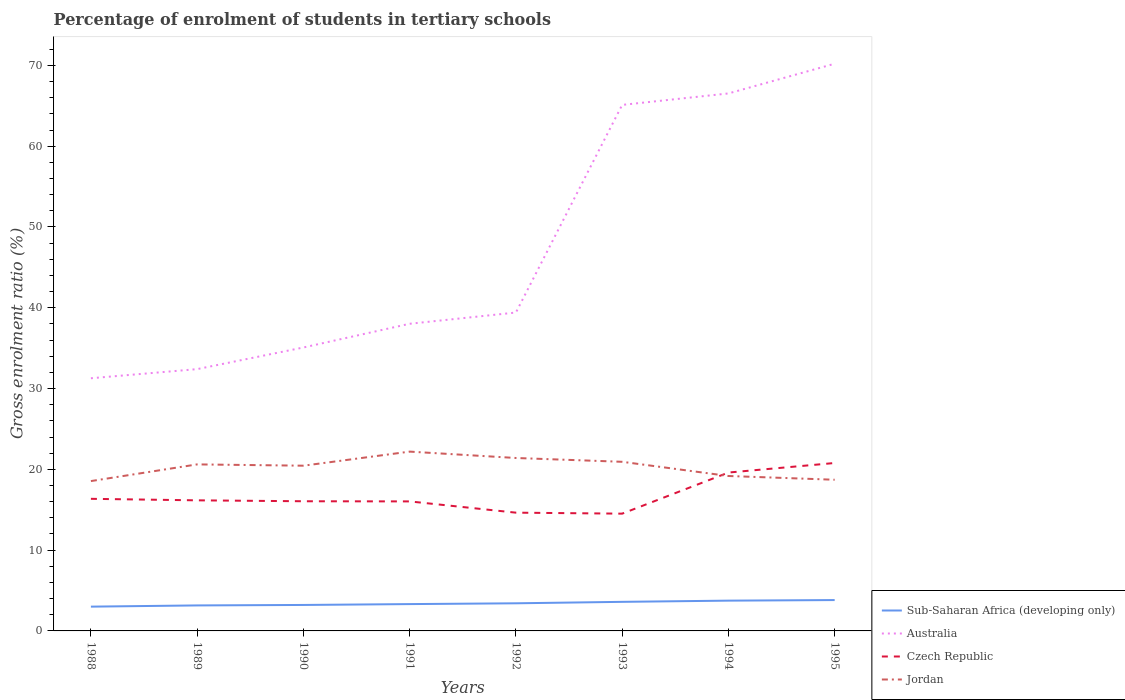Is the number of lines equal to the number of legend labels?
Keep it short and to the point. Yes. Across all years, what is the maximum percentage of students enrolled in tertiary schools in Australia?
Your answer should be very brief. 31.28. What is the total percentage of students enrolled in tertiary schools in Sub-Saharan Africa (developing only) in the graph?
Offer a terse response. -0.22. What is the difference between the highest and the second highest percentage of students enrolled in tertiary schools in Australia?
Keep it short and to the point. 38.93. What is the difference between two consecutive major ticks on the Y-axis?
Offer a very short reply. 10. Are the values on the major ticks of Y-axis written in scientific E-notation?
Make the answer very short. No. Where does the legend appear in the graph?
Give a very brief answer. Bottom right. What is the title of the graph?
Make the answer very short. Percentage of enrolment of students in tertiary schools. What is the label or title of the X-axis?
Provide a succinct answer. Years. What is the label or title of the Y-axis?
Your response must be concise. Gross enrolment ratio (%). What is the Gross enrolment ratio (%) in Sub-Saharan Africa (developing only) in 1988?
Give a very brief answer. 3. What is the Gross enrolment ratio (%) of Australia in 1988?
Ensure brevity in your answer.  31.28. What is the Gross enrolment ratio (%) in Czech Republic in 1988?
Ensure brevity in your answer.  16.35. What is the Gross enrolment ratio (%) in Jordan in 1988?
Offer a very short reply. 18.55. What is the Gross enrolment ratio (%) in Sub-Saharan Africa (developing only) in 1989?
Your answer should be very brief. 3.16. What is the Gross enrolment ratio (%) of Australia in 1989?
Ensure brevity in your answer.  32.41. What is the Gross enrolment ratio (%) of Czech Republic in 1989?
Your answer should be very brief. 16.16. What is the Gross enrolment ratio (%) in Jordan in 1989?
Offer a terse response. 20.61. What is the Gross enrolment ratio (%) in Sub-Saharan Africa (developing only) in 1990?
Make the answer very short. 3.21. What is the Gross enrolment ratio (%) of Australia in 1990?
Provide a succinct answer. 35.08. What is the Gross enrolment ratio (%) of Czech Republic in 1990?
Provide a short and direct response. 16.05. What is the Gross enrolment ratio (%) of Jordan in 1990?
Your answer should be compact. 20.45. What is the Gross enrolment ratio (%) in Sub-Saharan Africa (developing only) in 1991?
Your response must be concise. 3.32. What is the Gross enrolment ratio (%) of Australia in 1991?
Make the answer very short. 38.02. What is the Gross enrolment ratio (%) in Czech Republic in 1991?
Offer a very short reply. 16.03. What is the Gross enrolment ratio (%) of Jordan in 1991?
Your answer should be compact. 22.2. What is the Gross enrolment ratio (%) in Sub-Saharan Africa (developing only) in 1992?
Your answer should be very brief. 3.42. What is the Gross enrolment ratio (%) of Australia in 1992?
Give a very brief answer. 39.41. What is the Gross enrolment ratio (%) in Czech Republic in 1992?
Ensure brevity in your answer.  14.64. What is the Gross enrolment ratio (%) of Jordan in 1992?
Offer a terse response. 21.41. What is the Gross enrolment ratio (%) in Sub-Saharan Africa (developing only) in 1993?
Provide a short and direct response. 3.6. What is the Gross enrolment ratio (%) of Australia in 1993?
Give a very brief answer. 65.11. What is the Gross enrolment ratio (%) of Czech Republic in 1993?
Offer a very short reply. 14.52. What is the Gross enrolment ratio (%) in Jordan in 1993?
Ensure brevity in your answer.  20.93. What is the Gross enrolment ratio (%) in Sub-Saharan Africa (developing only) in 1994?
Ensure brevity in your answer.  3.75. What is the Gross enrolment ratio (%) in Australia in 1994?
Keep it short and to the point. 66.53. What is the Gross enrolment ratio (%) of Czech Republic in 1994?
Ensure brevity in your answer.  19.6. What is the Gross enrolment ratio (%) of Jordan in 1994?
Offer a terse response. 19.18. What is the Gross enrolment ratio (%) of Sub-Saharan Africa (developing only) in 1995?
Your answer should be compact. 3.82. What is the Gross enrolment ratio (%) of Australia in 1995?
Offer a very short reply. 70.21. What is the Gross enrolment ratio (%) of Czech Republic in 1995?
Your answer should be very brief. 20.79. What is the Gross enrolment ratio (%) in Jordan in 1995?
Ensure brevity in your answer.  18.71. Across all years, what is the maximum Gross enrolment ratio (%) in Sub-Saharan Africa (developing only)?
Provide a short and direct response. 3.82. Across all years, what is the maximum Gross enrolment ratio (%) in Australia?
Provide a short and direct response. 70.21. Across all years, what is the maximum Gross enrolment ratio (%) in Czech Republic?
Make the answer very short. 20.79. Across all years, what is the maximum Gross enrolment ratio (%) in Jordan?
Give a very brief answer. 22.2. Across all years, what is the minimum Gross enrolment ratio (%) of Sub-Saharan Africa (developing only)?
Your response must be concise. 3. Across all years, what is the minimum Gross enrolment ratio (%) in Australia?
Ensure brevity in your answer.  31.28. Across all years, what is the minimum Gross enrolment ratio (%) of Czech Republic?
Make the answer very short. 14.52. Across all years, what is the minimum Gross enrolment ratio (%) of Jordan?
Your answer should be compact. 18.55. What is the total Gross enrolment ratio (%) of Sub-Saharan Africa (developing only) in the graph?
Keep it short and to the point. 27.28. What is the total Gross enrolment ratio (%) in Australia in the graph?
Make the answer very short. 378.05. What is the total Gross enrolment ratio (%) in Czech Republic in the graph?
Your response must be concise. 134.14. What is the total Gross enrolment ratio (%) in Jordan in the graph?
Offer a very short reply. 162.04. What is the difference between the Gross enrolment ratio (%) of Sub-Saharan Africa (developing only) in 1988 and that in 1989?
Give a very brief answer. -0.15. What is the difference between the Gross enrolment ratio (%) of Australia in 1988 and that in 1989?
Your answer should be compact. -1.13. What is the difference between the Gross enrolment ratio (%) of Czech Republic in 1988 and that in 1989?
Keep it short and to the point. 0.19. What is the difference between the Gross enrolment ratio (%) in Jordan in 1988 and that in 1989?
Give a very brief answer. -2.07. What is the difference between the Gross enrolment ratio (%) of Sub-Saharan Africa (developing only) in 1988 and that in 1990?
Your answer should be compact. -0.21. What is the difference between the Gross enrolment ratio (%) in Australia in 1988 and that in 1990?
Offer a terse response. -3.81. What is the difference between the Gross enrolment ratio (%) of Czech Republic in 1988 and that in 1990?
Your response must be concise. 0.3. What is the difference between the Gross enrolment ratio (%) of Jordan in 1988 and that in 1990?
Provide a short and direct response. -1.9. What is the difference between the Gross enrolment ratio (%) in Sub-Saharan Africa (developing only) in 1988 and that in 1991?
Provide a succinct answer. -0.32. What is the difference between the Gross enrolment ratio (%) of Australia in 1988 and that in 1991?
Make the answer very short. -6.74. What is the difference between the Gross enrolment ratio (%) of Czech Republic in 1988 and that in 1991?
Provide a succinct answer. 0.32. What is the difference between the Gross enrolment ratio (%) of Jordan in 1988 and that in 1991?
Your answer should be very brief. -3.65. What is the difference between the Gross enrolment ratio (%) of Sub-Saharan Africa (developing only) in 1988 and that in 1992?
Offer a terse response. -0.41. What is the difference between the Gross enrolment ratio (%) of Australia in 1988 and that in 1992?
Give a very brief answer. -8.14. What is the difference between the Gross enrolment ratio (%) in Czech Republic in 1988 and that in 1992?
Offer a terse response. 1.71. What is the difference between the Gross enrolment ratio (%) in Jordan in 1988 and that in 1992?
Provide a short and direct response. -2.86. What is the difference between the Gross enrolment ratio (%) of Sub-Saharan Africa (developing only) in 1988 and that in 1993?
Ensure brevity in your answer.  -0.6. What is the difference between the Gross enrolment ratio (%) of Australia in 1988 and that in 1993?
Your answer should be very brief. -33.84. What is the difference between the Gross enrolment ratio (%) in Czech Republic in 1988 and that in 1993?
Offer a terse response. 1.84. What is the difference between the Gross enrolment ratio (%) in Jordan in 1988 and that in 1993?
Provide a short and direct response. -2.39. What is the difference between the Gross enrolment ratio (%) of Sub-Saharan Africa (developing only) in 1988 and that in 1994?
Offer a terse response. -0.74. What is the difference between the Gross enrolment ratio (%) of Australia in 1988 and that in 1994?
Make the answer very short. -35.25. What is the difference between the Gross enrolment ratio (%) of Czech Republic in 1988 and that in 1994?
Your answer should be very brief. -3.25. What is the difference between the Gross enrolment ratio (%) in Jordan in 1988 and that in 1994?
Your answer should be compact. -0.63. What is the difference between the Gross enrolment ratio (%) of Sub-Saharan Africa (developing only) in 1988 and that in 1995?
Keep it short and to the point. -0.81. What is the difference between the Gross enrolment ratio (%) in Australia in 1988 and that in 1995?
Your answer should be compact. -38.93. What is the difference between the Gross enrolment ratio (%) in Czech Republic in 1988 and that in 1995?
Your response must be concise. -4.43. What is the difference between the Gross enrolment ratio (%) in Jordan in 1988 and that in 1995?
Ensure brevity in your answer.  -0.16. What is the difference between the Gross enrolment ratio (%) of Sub-Saharan Africa (developing only) in 1989 and that in 1990?
Give a very brief answer. -0.06. What is the difference between the Gross enrolment ratio (%) in Australia in 1989 and that in 1990?
Make the answer very short. -2.68. What is the difference between the Gross enrolment ratio (%) in Czech Republic in 1989 and that in 1990?
Your response must be concise. 0.11. What is the difference between the Gross enrolment ratio (%) in Jordan in 1989 and that in 1990?
Ensure brevity in your answer.  0.16. What is the difference between the Gross enrolment ratio (%) in Sub-Saharan Africa (developing only) in 1989 and that in 1991?
Your response must be concise. -0.16. What is the difference between the Gross enrolment ratio (%) in Australia in 1989 and that in 1991?
Provide a succinct answer. -5.61. What is the difference between the Gross enrolment ratio (%) in Czech Republic in 1989 and that in 1991?
Provide a succinct answer. 0.13. What is the difference between the Gross enrolment ratio (%) in Jordan in 1989 and that in 1991?
Make the answer very short. -1.58. What is the difference between the Gross enrolment ratio (%) of Sub-Saharan Africa (developing only) in 1989 and that in 1992?
Offer a terse response. -0.26. What is the difference between the Gross enrolment ratio (%) of Australia in 1989 and that in 1992?
Give a very brief answer. -7.01. What is the difference between the Gross enrolment ratio (%) in Czech Republic in 1989 and that in 1992?
Offer a terse response. 1.53. What is the difference between the Gross enrolment ratio (%) in Jordan in 1989 and that in 1992?
Your answer should be compact. -0.79. What is the difference between the Gross enrolment ratio (%) in Sub-Saharan Africa (developing only) in 1989 and that in 1993?
Your response must be concise. -0.44. What is the difference between the Gross enrolment ratio (%) in Australia in 1989 and that in 1993?
Give a very brief answer. -32.7. What is the difference between the Gross enrolment ratio (%) of Czech Republic in 1989 and that in 1993?
Offer a terse response. 1.65. What is the difference between the Gross enrolment ratio (%) of Jordan in 1989 and that in 1993?
Your answer should be compact. -0.32. What is the difference between the Gross enrolment ratio (%) in Sub-Saharan Africa (developing only) in 1989 and that in 1994?
Ensure brevity in your answer.  -0.59. What is the difference between the Gross enrolment ratio (%) in Australia in 1989 and that in 1994?
Make the answer very short. -34.12. What is the difference between the Gross enrolment ratio (%) in Czech Republic in 1989 and that in 1994?
Your response must be concise. -3.44. What is the difference between the Gross enrolment ratio (%) in Jordan in 1989 and that in 1994?
Offer a very short reply. 1.44. What is the difference between the Gross enrolment ratio (%) in Sub-Saharan Africa (developing only) in 1989 and that in 1995?
Make the answer very short. -0.66. What is the difference between the Gross enrolment ratio (%) in Australia in 1989 and that in 1995?
Offer a very short reply. -37.8. What is the difference between the Gross enrolment ratio (%) in Czech Republic in 1989 and that in 1995?
Make the answer very short. -4.62. What is the difference between the Gross enrolment ratio (%) in Jordan in 1989 and that in 1995?
Offer a very short reply. 1.9. What is the difference between the Gross enrolment ratio (%) in Sub-Saharan Africa (developing only) in 1990 and that in 1991?
Provide a short and direct response. -0.11. What is the difference between the Gross enrolment ratio (%) of Australia in 1990 and that in 1991?
Your answer should be compact. -2.94. What is the difference between the Gross enrolment ratio (%) in Czech Republic in 1990 and that in 1991?
Your response must be concise. 0.02. What is the difference between the Gross enrolment ratio (%) in Jordan in 1990 and that in 1991?
Make the answer very short. -1.74. What is the difference between the Gross enrolment ratio (%) in Sub-Saharan Africa (developing only) in 1990 and that in 1992?
Your answer should be compact. -0.2. What is the difference between the Gross enrolment ratio (%) of Australia in 1990 and that in 1992?
Keep it short and to the point. -4.33. What is the difference between the Gross enrolment ratio (%) in Czech Republic in 1990 and that in 1992?
Offer a very short reply. 1.41. What is the difference between the Gross enrolment ratio (%) in Jordan in 1990 and that in 1992?
Offer a very short reply. -0.95. What is the difference between the Gross enrolment ratio (%) of Sub-Saharan Africa (developing only) in 1990 and that in 1993?
Offer a very short reply. -0.39. What is the difference between the Gross enrolment ratio (%) of Australia in 1990 and that in 1993?
Provide a short and direct response. -30.03. What is the difference between the Gross enrolment ratio (%) of Czech Republic in 1990 and that in 1993?
Make the answer very short. 1.53. What is the difference between the Gross enrolment ratio (%) in Jordan in 1990 and that in 1993?
Keep it short and to the point. -0.48. What is the difference between the Gross enrolment ratio (%) of Sub-Saharan Africa (developing only) in 1990 and that in 1994?
Your answer should be compact. -0.53. What is the difference between the Gross enrolment ratio (%) of Australia in 1990 and that in 1994?
Your response must be concise. -31.45. What is the difference between the Gross enrolment ratio (%) of Czech Republic in 1990 and that in 1994?
Provide a succinct answer. -3.55. What is the difference between the Gross enrolment ratio (%) in Jordan in 1990 and that in 1994?
Your response must be concise. 1.27. What is the difference between the Gross enrolment ratio (%) of Sub-Saharan Africa (developing only) in 1990 and that in 1995?
Make the answer very short. -0.6. What is the difference between the Gross enrolment ratio (%) in Australia in 1990 and that in 1995?
Ensure brevity in your answer.  -35.12. What is the difference between the Gross enrolment ratio (%) of Czech Republic in 1990 and that in 1995?
Your response must be concise. -4.74. What is the difference between the Gross enrolment ratio (%) of Jordan in 1990 and that in 1995?
Your answer should be compact. 1.74. What is the difference between the Gross enrolment ratio (%) of Sub-Saharan Africa (developing only) in 1991 and that in 1992?
Ensure brevity in your answer.  -0.1. What is the difference between the Gross enrolment ratio (%) of Australia in 1991 and that in 1992?
Offer a terse response. -1.39. What is the difference between the Gross enrolment ratio (%) in Czech Republic in 1991 and that in 1992?
Give a very brief answer. 1.39. What is the difference between the Gross enrolment ratio (%) of Jordan in 1991 and that in 1992?
Offer a terse response. 0.79. What is the difference between the Gross enrolment ratio (%) of Sub-Saharan Africa (developing only) in 1991 and that in 1993?
Offer a terse response. -0.28. What is the difference between the Gross enrolment ratio (%) in Australia in 1991 and that in 1993?
Offer a terse response. -27.09. What is the difference between the Gross enrolment ratio (%) of Czech Republic in 1991 and that in 1993?
Offer a terse response. 1.52. What is the difference between the Gross enrolment ratio (%) of Jordan in 1991 and that in 1993?
Your answer should be very brief. 1.26. What is the difference between the Gross enrolment ratio (%) of Sub-Saharan Africa (developing only) in 1991 and that in 1994?
Your answer should be very brief. -0.43. What is the difference between the Gross enrolment ratio (%) in Australia in 1991 and that in 1994?
Make the answer very short. -28.51. What is the difference between the Gross enrolment ratio (%) of Czech Republic in 1991 and that in 1994?
Offer a terse response. -3.57. What is the difference between the Gross enrolment ratio (%) in Jordan in 1991 and that in 1994?
Your answer should be compact. 3.02. What is the difference between the Gross enrolment ratio (%) of Sub-Saharan Africa (developing only) in 1991 and that in 1995?
Your response must be concise. -0.5. What is the difference between the Gross enrolment ratio (%) in Australia in 1991 and that in 1995?
Ensure brevity in your answer.  -32.19. What is the difference between the Gross enrolment ratio (%) in Czech Republic in 1991 and that in 1995?
Keep it short and to the point. -4.75. What is the difference between the Gross enrolment ratio (%) in Jordan in 1991 and that in 1995?
Offer a very short reply. 3.48. What is the difference between the Gross enrolment ratio (%) in Sub-Saharan Africa (developing only) in 1992 and that in 1993?
Ensure brevity in your answer.  -0.18. What is the difference between the Gross enrolment ratio (%) of Australia in 1992 and that in 1993?
Your answer should be compact. -25.7. What is the difference between the Gross enrolment ratio (%) in Czech Republic in 1992 and that in 1993?
Ensure brevity in your answer.  0.12. What is the difference between the Gross enrolment ratio (%) in Jordan in 1992 and that in 1993?
Make the answer very short. 0.47. What is the difference between the Gross enrolment ratio (%) in Sub-Saharan Africa (developing only) in 1992 and that in 1994?
Make the answer very short. -0.33. What is the difference between the Gross enrolment ratio (%) of Australia in 1992 and that in 1994?
Provide a succinct answer. -27.12. What is the difference between the Gross enrolment ratio (%) in Czech Republic in 1992 and that in 1994?
Keep it short and to the point. -4.97. What is the difference between the Gross enrolment ratio (%) in Jordan in 1992 and that in 1994?
Provide a succinct answer. 2.23. What is the difference between the Gross enrolment ratio (%) in Sub-Saharan Africa (developing only) in 1992 and that in 1995?
Give a very brief answer. -0.4. What is the difference between the Gross enrolment ratio (%) of Australia in 1992 and that in 1995?
Your answer should be compact. -30.8. What is the difference between the Gross enrolment ratio (%) of Czech Republic in 1992 and that in 1995?
Keep it short and to the point. -6.15. What is the difference between the Gross enrolment ratio (%) in Jordan in 1992 and that in 1995?
Make the answer very short. 2.69. What is the difference between the Gross enrolment ratio (%) of Sub-Saharan Africa (developing only) in 1993 and that in 1994?
Your answer should be very brief. -0.15. What is the difference between the Gross enrolment ratio (%) of Australia in 1993 and that in 1994?
Offer a terse response. -1.42. What is the difference between the Gross enrolment ratio (%) in Czech Republic in 1993 and that in 1994?
Your answer should be compact. -5.09. What is the difference between the Gross enrolment ratio (%) of Jordan in 1993 and that in 1994?
Your answer should be compact. 1.76. What is the difference between the Gross enrolment ratio (%) of Sub-Saharan Africa (developing only) in 1993 and that in 1995?
Provide a succinct answer. -0.22. What is the difference between the Gross enrolment ratio (%) of Australia in 1993 and that in 1995?
Your answer should be compact. -5.1. What is the difference between the Gross enrolment ratio (%) of Czech Republic in 1993 and that in 1995?
Keep it short and to the point. -6.27. What is the difference between the Gross enrolment ratio (%) of Jordan in 1993 and that in 1995?
Offer a very short reply. 2.22. What is the difference between the Gross enrolment ratio (%) in Sub-Saharan Africa (developing only) in 1994 and that in 1995?
Offer a terse response. -0.07. What is the difference between the Gross enrolment ratio (%) of Australia in 1994 and that in 1995?
Offer a terse response. -3.68. What is the difference between the Gross enrolment ratio (%) of Czech Republic in 1994 and that in 1995?
Provide a succinct answer. -1.18. What is the difference between the Gross enrolment ratio (%) in Jordan in 1994 and that in 1995?
Give a very brief answer. 0.47. What is the difference between the Gross enrolment ratio (%) in Sub-Saharan Africa (developing only) in 1988 and the Gross enrolment ratio (%) in Australia in 1989?
Your response must be concise. -29.4. What is the difference between the Gross enrolment ratio (%) of Sub-Saharan Africa (developing only) in 1988 and the Gross enrolment ratio (%) of Czech Republic in 1989?
Keep it short and to the point. -13.16. What is the difference between the Gross enrolment ratio (%) in Sub-Saharan Africa (developing only) in 1988 and the Gross enrolment ratio (%) in Jordan in 1989?
Your answer should be compact. -17.61. What is the difference between the Gross enrolment ratio (%) in Australia in 1988 and the Gross enrolment ratio (%) in Czech Republic in 1989?
Your answer should be very brief. 15.11. What is the difference between the Gross enrolment ratio (%) of Australia in 1988 and the Gross enrolment ratio (%) of Jordan in 1989?
Your answer should be compact. 10.66. What is the difference between the Gross enrolment ratio (%) in Czech Republic in 1988 and the Gross enrolment ratio (%) in Jordan in 1989?
Offer a very short reply. -4.26. What is the difference between the Gross enrolment ratio (%) of Sub-Saharan Africa (developing only) in 1988 and the Gross enrolment ratio (%) of Australia in 1990?
Provide a succinct answer. -32.08. What is the difference between the Gross enrolment ratio (%) of Sub-Saharan Africa (developing only) in 1988 and the Gross enrolment ratio (%) of Czech Republic in 1990?
Your answer should be very brief. -13.05. What is the difference between the Gross enrolment ratio (%) in Sub-Saharan Africa (developing only) in 1988 and the Gross enrolment ratio (%) in Jordan in 1990?
Provide a succinct answer. -17.45. What is the difference between the Gross enrolment ratio (%) in Australia in 1988 and the Gross enrolment ratio (%) in Czech Republic in 1990?
Provide a succinct answer. 15.22. What is the difference between the Gross enrolment ratio (%) of Australia in 1988 and the Gross enrolment ratio (%) of Jordan in 1990?
Make the answer very short. 10.82. What is the difference between the Gross enrolment ratio (%) in Czech Republic in 1988 and the Gross enrolment ratio (%) in Jordan in 1990?
Make the answer very short. -4.1. What is the difference between the Gross enrolment ratio (%) of Sub-Saharan Africa (developing only) in 1988 and the Gross enrolment ratio (%) of Australia in 1991?
Your response must be concise. -35.02. What is the difference between the Gross enrolment ratio (%) in Sub-Saharan Africa (developing only) in 1988 and the Gross enrolment ratio (%) in Czech Republic in 1991?
Give a very brief answer. -13.03. What is the difference between the Gross enrolment ratio (%) in Sub-Saharan Africa (developing only) in 1988 and the Gross enrolment ratio (%) in Jordan in 1991?
Give a very brief answer. -19.19. What is the difference between the Gross enrolment ratio (%) in Australia in 1988 and the Gross enrolment ratio (%) in Czech Republic in 1991?
Give a very brief answer. 15.24. What is the difference between the Gross enrolment ratio (%) of Australia in 1988 and the Gross enrolment ratio (%) of Jordan in 1991?
Provide a succinct answer. 9.08. What is the difference between the Gross enrolment ratio (%) of Czech Republic in 1988 and the Gross enrolment ratio (%) of Jordan in 1991?
Ensure brevity in your answer.  -5.84. What is the difference between the Gross enrolment ratio (%) of Sub-Saharan Africa (developing only) in 1988 and the Gross enrolment ratio (%) of Australia in 1992?
Provide a short and direct response. -36.41. What is the difference between the Gross enrolment ratio (%) in Sub-Saharan Africa (developing only) in 1988 and the Gross enrolment ratio (%) in Czech Republic in 1992?
Provide a succinct answer. -11.63. What is the difference between the Gross enrolment ratio (%) in Sub-Saharan Africa (developing only) in 1988 and the Gross enrolment ratio (%) in Jordan in 1992?
Provide a succinct answer. -18.4. What is the difference between the Gross enrolment ratio (%) in Australia in 1988 and the Gross enrolment ratio (%) in Czech Republic in 1992?
Make the answer very short. 16.64. What is the difference between the Gross enrolment ratio (%) of Australia in 1988 and the Gross enrolment ratio (%) of Jordan in 1992?
Your answer should be very brief. 9.87. What is the difference between the Gross enrolment ratio (%) in Czech Republic in 1988 and the Gross enrolment ratio (%) in Jordan in 1992?
Offer a terse response. -5.05. What is the difference between the Gross enrolment ratio (%) of Sub-Saharan Africa (developing only) in 1988 and the Gross enrolment ratio (%) of Australia in 1993?
Offer a very short reply. -62.11. What is the difference between the Gross enrolment ratio (%) in Sub-Saharan Africa (developing only) in 1988 and the Gross enrolment ratio (%) in Czech Republic in 1993?
Your answer should be very brief. -11.51. What is the difference between the Gross enrolment ratio (%) of Sub-Saharan Africa (developing only) in 1988 and the Gross enrolment ratio (%) of Jordan in 1993?
Your answer should be very brief. -17.93. What is the difference between the Gross enrolment ratio (%) in Australia in 1988 and the Gross enrolment ratio (%) in Czech Republic in 1993?
Offer a terse response. 16.76. What is the difference between the Gross enrolment ratio (%) in Australia in 1988 and the Gross enrolment ratio (%) in Jordan in 1993?
Your answer should be very brief. 10.34. What is the difference between the Gross enrolment ratio (%) in Czech Republic in 1988 and the Gross enrolment ratio (%) in Jordan in 1993?
Ensure brevity in your answer.  -4.58. What is the difference between the Gross enrolment ratio (%) of Sub-Saharan Africa (developing only) in 1988 and the Gross enrolment ratio (%) of Australia in 1994?
Provide a succinct answer. -63.53. What is the difference between the Gross enrolment ratio (%) in Sub-Saharan Africa (developing only) in 1988 and the Gross enrolment ratio (%) in Czech Republic in 1994?
Your response must be concise. -16.6. What is the difference between the Gross enrolment ratio (%) in Sub-Saharan Africa (developing only) in 1988 and the Gross enrolment ratio (%) in Jordan in 1994?
Give a very brief answer. -16.17. What is the difference between the Gross enrolment ratio (%) in Australia in 1988 and the Gross enrolment ratio (%) in Czech Republic in 1994?
Give a very brief answer. 11.67. What is the difference between the Gross enrolment ratio (%) of Australia in 1988 and the Gross enrolment ratio (%) of Jordan in 1994?
Offer a terse response. 12.1. What is the difference between the Gross enrolment ratio (%) of Czech Republic in 1988 and the Gross enrolment ratio (%) of Jordan in 1994?
Offer a very short reply. -2.83. What is the difference between the Gross enrolment ratio (%) of Sub-Saharan Africa (developing only) in 1988 and the Gross enrolment ratio (%) of Australia in 1995?
Your answer should be compact. -67.2. What is the difference between the Gross enrolment ratio (%) of Sub-Saharan Africa (developing only) in 1988 and the Gross enrolment ratio (%) of Czech Republic in 1995?
Keep it short and to the point. -17.78. What is the difference between the Gross enrolment ratio (%) in Sub-Saharan Africa (developing only) in 1988 and the Gross enrolment ratio (%) in Jordan in 1995?
Give a very brief answer. -15.71. What is the difference between the Gross enrolment ratio (%) in Australia in 1988 and the Gross enrolment ratio (%) in Czech Republic in 1995?
Make the answer very short. 10.49. What is the difference between the Gross enrolment ratio (%) in Australia in 1988 and the Gross enrolment ratio (%) in Jordan in 1995?
Your answer should be compact. 12.56. What is the difference between the Gross enrolment ratio (%) of Czech Republic in 1988 and the Gross enrolment ratio (%) of Jordan in 1995?
Ensure brevity in your answer.  -2.36. What is the difference between the Gross enrolment ratio (%) of Sub-Saharan Africa (developing only) in 1989 and the Gross enrolment ratio (%) of Australia in 1990?
Give a very brief answer. -31.93. What is the difference between the Gross enrolment ratio (%) of Sub-Saharan Africa (developing only) in 1989 and the Gross enrolment ratio (%) of Czech Republic in 1990?
Make the answer very short. -12.89. What is the difference between the Gross enrolment ratio (%) of Sub-Saharan Africa (developing only) in 1989 and the Gross enrolment ratio (%) of Jordan in 1990?
Provide a succinct answer. -17.3. What is the difference between the Gross enrolment ratio (%) in Australia in 1989 and the Gross enrolment ratio (%) in Czech Republic in 1990?
Provide a short and direct response. 16.36. What is the difference between the Gross enrolment ratio (%) in Australia in 1989 and the Gross enrolment ratio (%) in Jordan in 1990?
Your response must be concise. 11.95. What is the difference between the Gross enrolment ratio (%) in Czech Republic in 1989 and the Gross enrolment ratio (%) in Jordan in 1990?
Ensure brevity in your answer.  -4.29. What is the difference between the Gross enrolment ratio (%) in Sub-Saharan Africa (developing only) in 1989 and the Gross enrolment ratio (%) in Australia in 1991?
Ensure brevity in your answer.  -34.86. What is the difference between the Gross enrolment ratio (%) of Sub-Saharan Africa (developing only) in 1989 and the Gross enrolment ratio (%) of Czech Republic in 1991?
Offer a terse response. -12.88. What is the difference between the Gross enrolment ratio (%) of Sub-Saharan Africa (developing only) in 1989 and the Gross enrolment ratio (%) of Jordan in 1991?
Provide a succinct answer. -19.04. What is the difference between the Gross enrolment ratio (%) in Australia in 1989 and the Gross enrolment ratio (%) in Czech Republic in 1991?
Offer a very short reply. 16.37. What is the difference between the Gross enrolment ratio (%) of Australia in 1989 and the Gross enrolment ratio (%) of Jordan in 1991?
Keep it short and to the point. 10.21. What is the difference between the Gross enrolment ratio (%) of Czech Republic in 1989 and the Gross enrolment ratio (%) of Jordan in 1991?
Keep it short and to the point. -6.03. What is the difference between the Gross enrolment ratio (%) in Sub-Saharan Africa (developing only) in 1989 and the Gross enrolment ratio (%) in Australia in 1992?
Your answer should be very brief. -36.25. What is the difference between the Gross enrolment ratio (%) in Sub-Saharan Africa (developing only) in 1989 and the Gross enrolment ratio (%) in Czech Republic in 1992?
Offer a terse response. -11.48. What is the difference between the Gross enrolment ratio (%) of Sub-Saharan Africa (developing only) in 1989 and the Gross enrolment ratio (%) of Jordan in 1992?
Your answer should be very brief. -18.25. What is the difference between the Gross enrolment ratio (%) of Australia in 1989 and the Gross enrolment ratio (%) of Czech Republic in 1992?
Your answer should be very brief. 17.77. What is the difference between the Gross enrolment ratio (%) of Australia in 1989 and the Gross enrolment ratio (%) of Jordan in 1992?
Offer a terse response. 11. What is the difference between the Gross enrolment ratio (%) in Czech Republic in 1989 and the Gross enrolment ratio (%) in Jordan in 1992?
Your answer should be compact. -5.24. What is the difference between the Gross enrolment ratio (%) in Sub-Saharan Africa (developing only) in 1989 and the Gross enrolment ratio (%) in Australia in 1993?
Your answer should be very brief. -61.95. What is the difference between the Gross enrolment ratio (%) in Sub-Saharan Africa (developing only) in 1989 and the Gross enrolment ratio (%) in Czech Republic in 1993?
Give a very brief answer. -11.36. What is the difference between the Gross enrolment ratio (%) of Sub-Saharan Africa (developing only) in 1989 and the Gross enrolment ratio (%) of Jordan in 1993?
Ensure brevity in your answer.  -17.78. What is the difference between the Gross enrolment ratio (%) of Australia in 1989 and the Gross enrolment ratio (%) of Czech Republic in 1993?
Make the answer very short. 17.89. What is the difference between the Gross enrolment ratio (%) in Australia in 1989 and the Gross enrolment ratio (%) in Jordan in 1993?
Your answer should be compact. 11.47. What is the difference between the Gross enrolment ratio (%) of Czech Republic in 1989 and the Gross enrolment ratio (%) of Jordan in 1993?
Offer a very short reply. -4.77. What is the difference between the Gross enrolment ratio (%) of Sub-Saharan Africa (developing only) in 1989 and the Gross enrolment ratio (%) of Australia in 1994?
Keep it short and to the point. -63.37. What is the difference between the Gross enrolment ratio (%) of Sub-Saharan Africa (developing only) in 1989 and the Gross enrolment ratio (%) of Czech Republic in 1994?
Provide a succinct answer. -16.45. What is the difference between the Gross enrolment ratio (%) of Sub-Saharan Africa (developing only) in 1989 and the Gross enrolment ratio (%) of Jordan in 1994?
Your response must be concise. -16.02. What is the difference between the Gross enrolment ratio (%) of Australia in 1989 and the Gross enrolment ratio (%) of Czech Republic in 1994?
Your answer should be very brief. 12.8. What is the difference between the Gross enrolment ratio (%) in Australia in 1989 and the Gross enrolment ratio (%) in Jordan in 1994?
Offer a terse response. 13.23. What is the difference between the Gross enrolment ratio (%) of Czech Republic in 1989 and the Gross enrolment ratio (%) of Jordan in 1994?
Make the answer very short. -3.01. What is the difference between the Gross enrolment ratio (%) of Sub-Saharan Africa (developing only) in 1989 and the Gross enrolment ratio (%) of Australia in 1995?
Keep it short and to the point. -67.05. What is the difference between the Gross enrolment ratio (%) of Sub-Saharan Africa (developing only) in 1989 and the Gross enrolment ratio (%) of Czech Republic in 1995?
Your response must be concise. -17.63. What is the difference between the Gross enrolment ratio (%) of Sub-Saharan Africa (developing only) in 1989 and the Gross enrolment ratio (%) of Jordan in 1995?
Your answer should be very brief. -15.56. What is the difference between the Gross enrolment ratio (%) of Australia in 1989 and the Gross enrolment ratio (%) of Czech Republic in 1995?
Provide a short and direct response. 11.62. What is the difference between the Gross enrolment ratio (%) of Australia in 1989 and the Gross enrolment ratio (%) of Jordan in 1995?
Provide a short and direct response. 13.69. What is the difference between the Gross enrolment ratio (%) of Czech Republic in 1989 and the Gross enrolment ratio (%) of Jordan in 1995?
Make the answer very short. -2.55. What is the difference between the Gross enrolment ratio (%) in Sub-Saharan Africa (developing only) in 1990 and the Gross enrolment ratio (%) in Australia in 1991?
Your response must be concise. -34.81. What is the difference between the Gross enrolment ratio (%) in Sub-Saharan Africa (developing only) in 1990 and the Gross enrolment ratio (%) in Czech Republic in 1991?
Provide a short and direct response. -12.82. What is the difference between the Gross enrolment ratio (%) of Sub-Saharan Africa (developing only) in 1990 and the Gross enrolment ratio (%) of Jordan in 1991?
Make the answer very short. -18.98. What is the difference between the Gross enrolment ratio (%) in Australia in 1990 and the Gross enrolment ratio (%) in Czech Republic in 1991?
Give a very brief answer. 19.05. What is the difference between the Gross enrolment ratio (%) of Australia in 1990 and the Gross enrolment ratio (%) of Jordan in 1991?
Provide a short and direct response. 12.89. What is the difference between the Gross enrolment ratio (%) in Czech Republic in 1990 and the Gross enrolment ratio (%) in Jordan in 1991?
Ensure brevity in your answer.  -6.14. What is the difference between the Gross enrolment ratio (%) in Sub-Saharan Africa (developing only) in 1990 and the Gross enrolment ratio (%) in Australia in 1992?
Your answer should be compact. -36.2. What is the difference between the Gross enrolment ratio (%) in Sub-Saharan Africa (developing only) in 1990 and the Gross enrolment ratio (%) in Czech Republic in 1992?
Make the answer very short. -11.42. What is the difference between the Gross enrolment ratio (%) in Sub-Saharan Africa (developing only) in 1990 and the Gross enrolment ratio (%) in Jordan in 1992?
Your answer should be compact. -18.19. What is the difference between the Gross enrolment ratio (%) in Australia in 1990 and the Gross enrolment ratio (%) in Czech Republic in 1992?
Provide a short and direct response. 20.45. What is the difference between the Gross enrolment ratio (%) of Australia in 1990 and the Gross enrolment ratio (%) of Jordan in 1992?
Ensure brevity in your answer.  13.68. What is the difference between the Gross enrolment ratio (%) of Czech Republic in 1990 and the Gross enrolment ratio (%) of Jordan in 1992?
Ensure brevity in your answer.  -5.36. What is the difference between the Gross enrolment ratio (%) in Sub-Saharan Africa (developing only) in 1990 and the Gross enrolment ratio (%) in Australia in 1993?
Provide a succinct answer. -61.9. What is the difference between the Gross enrolment ratio (%) of Sub-Saharan Africa (developing only) in 1990 and the Gross enrolment ratio (%) of Czech Republic in 1993?
Your answer should be very brief. -11.3. What is the difference between the Gross enrolment ratio (%) of Sub-Saharan Africa (developing only) in 1990 and the Gross enrolment ratio (%) of Jordan in 1993?
Give a very brief answer. -17.72. What is the difference between the Gross enrolment ratio (%) in Australia in 1990 and the Gross enrolment ratio (%) in Czech Republic in 1993?
Offer a terse response. 20.57. What is the difference between the Gross enrolment ratio (%) in Australia in 1990 and the Gross enrolment ratio (%) in Jordan in 1993?
Offer a very short reply. 14.15. What is the difference between the Gross enrolment ratio (%) of Czech Republic in 1990 and the Gross enrolment ratio (%) of Jordan in 1993?
Provide a short and direct response. -4.88. What is the difference between the Gross enrolment ratio (%) in Sub-Saharan Africa (developing only) in 1990 and the Gross enrolment ratio (%) in Australia in 1994?
Make the answer very short. -63.32. What is the difference between the Gross enrolment ratio (%) of Sub-Saharan Africa (developing only) in 1990 and the Gross enrolment ratio (%) of Czech Republic in 1994?
Your answer should be compact. -16.39. What is the difference between the Gross enrolment ratio (%) in Sub-Saharan Africa (developing only) in 1990 and the Gross enrolment ratio (%) in Jordan in 1994?
Ensure brevity in your answer.  -15.96. What is the difference between the Gross enrolment ratio (%) in Australia in 1990 and the Gross enrolment ratio (%) in Czech Republic in 1994?
Provide a short and direct response. 15.48. What is the difference between the Gross enrolment ratio (%) in Australia in 1990 and the Gross enrolment ratio (%) in Jordan in 1994?
Provide a succinct answer. 15.91. What is the difference between the Gross enrolment ratio (%) of Czech Republic in 1990 and the Gross enrolment ratio (%) of Jordan in 1994?
Provide a succinct answer. -3.13. What is the difference between the Gross enrolment ratio (%) in Sub-Saharan Africa (developing only) in 1990 and the Gross enrolment ratio (%) in Australia in 1995?
Your answer should be compact. -66.99. What is the difference between the Gross enrolment ratio (%) in Sub-Saharan Africa (developing only) in 1990 and the Gross enrolment ratio (%) in Czech Republic in 1995?
Ensure brevity in your answer.  -17.57. What is the difference between the Gross enrolment ratio (%) of Sub-Saharan Africa (developing only) in 1990 and the Gross enrolment ratio (%) of Jordan in 1995?
Your answer should be compact. -15.5. What is the difference between the Gross enrolment ratio (%) of Australia in 1990 and the Gross enrolment ratio (%) of Czech Republic in 1995?
Give a very brief answer. 14.3. What is the difference between the Gross enrolment ratio (%) of Australia in 1990 and the Gross enrolment ratio (%) of Jordan in 1995?
Make the answer very short. 16.37. What is the difference between the Gross enrolment ratio (%) of Czech Republic in 1990 and the Gross enrolment ratio (%) of Jordan in 1995?
Your response must be concise. -2.66. What is the difference between the Gross enrolment ratio (%) in Sub-Saharan Africa (developing only) in 1991 and the Gross enrolment ratio (%) in Australia in 1992?
Give a very brief answer. -36.09. What is the difference between the Gross enrolment ratio (%) in Sub-Saharan Africa (developing only) in 1991 and the Gross enrolment ratio (%) in Czech Republic in 1992?
Your answer should be very brief. -11.32. What is the difference between the Gross enrolment ratio (%) in Sub-Saharan Africa (developing only) in 1991 and the Gross enrolment ratio (%) in Jordan in 1992?
Offer a very short reply. -18.09. What is the difference between the Gross enrolment ratio (%) of Australia in 1991 and the Gross enrolment ratio (%) of Czech Republic in 1992?
Provide a succinct answer. 23.38. What is the difference between the Gross enrolment ratio (%) of Australia in 1991 and the Gross enrolment ratio (%) of Jordan in 1992?
Your answer should be compact. 16.61. What is the difference between the Gross enrolment ratio (%) in Czech Republic in 1991 and the Gross enrolment ratio (%) in Jordan in 1992?
Make the answer very short. -5.37. What is the difference between the Gross enrolment ratio (%) in Sub-Saharan Africa (developing only) in 1991 and the Gross enrolment ratio (%) in Australia in 1993?
Offer a terse response. -61.79. What is the difference between the Gross enrolment ratio (%) of Sub-Saharan Africa (developing only) in 1991 and the Gross enrolment ratio (%) of Czech Republic in 1993?
Your response must be concise. -11.2. What is the difference between the Gross enrolment ratio (%) of Sub-Saharan Africa (developing only) in 1991 and the Gross enrolment ratio (%) of Jordan in 1993?
Your answer should be very brief. -17.61. What is the difference between the Gross enrolment ratio (%) in Australia in 1991 and the Gross enrolment ratio (%) in Czech Republic in 1993?
Ensure brevity in your answer.  23.5. What is the difference between the Gross enrolment ratio (%) in Australia in 1991 and the Gross enrolment ratio (%) in Jordan in 1993?
Provide a succinct answer. 17.09. What is the difference between the Gross enrolment ratio (%) in Czech Republic in 1991 and the Gross enrolment ratio (%) in Jordan in 1993?
Offer a very short reply. -4.9. What is the difference between the Gross enrolment ratio (%) of Sub-Saharan Africa (developing only) in 1991 and the Gross enrolment ratio (%) of Australia in 1994?
Your answer should be compact. -63.21. What is the difference between the Gross enrolment ratio (%) in Sub-Saharan Africa (developing only) in 1991 and the Gross enrolment ratio (%) in Czech Republic in 1994?
Give a very brief answer. -16.28. What is the difference between the Gross enrolment ratio (%) in Sub-Saharan Africa (developing only) in 1991 and the Gross enrolment ratio (%) in Jordan in 1994?
Offer a very short reply. -15.86. What is the difference between the Gross enrolment ratio (%) in Australia in 1991 and the Gross enrolment ratio (%) in Czech Republic in 1994?
Offer a terse response. 18.42. What is the difference between the Gross enrolment ratio (%) in Australia in 1991 and the Gross enrolment ratio (%) in Jordan in 1994?
Provide a succinct answer. 18.84. What is the difference between the Gross enrolment ratio (%) in Czech Republic in 1991 and the Gross enrolment ratio (%) in Jordan in 1994?
Give a very brief answer. -3.15. What is the difference between the Gross enrolment ratio (%) of Sub-Saharan Africa (developing only) in 1991 and the Gross enrolment ratio (%) of Australia in 1995?
Give a very brief answer. -66.89. What is the difference between the Gross enrolment ratio (%) of Sub-Saharan Africa (developing only) in 1991 and the Gross enrolment ratio (%) of Czech Republic in 1995?
Keep it short and to the point. -17.47. What is the difference between the Gross enrolment ratio (%) of Sub-Saharan Africa (developing only) in 1991 and the Gross enrolment ratio (%) of Jordan in 1995?
Provide a succinct answer. -15.39. What is the difference between the Gross enrolment ratio (%) in Australia in 1991 and the Gross enrolment ratio (%) in Czech Republic in 1995?
Provide a short and direct response. 17.23. What is the difference between the Gross enrolment ratio (%) in Australia in 1991 and the Gross enrolment ratio (%) in Jordan in 1995?
Provide a succinct answer. 19.31. What is the difference between the Gross enrolment ratio (%) in Czech Republic in 1991 and the Gross enrolment ratio (%) in Jordan in 1995?
Offer a terse response. -2.68. What is the difference between the Gross enrolment ratio (%) of Sub-Saharan Africa (developing only) in 1992 and the Gross enrolment ratio (%) of Australia in 1993?
Offer a terse response. -61.69. What is the difference between the Gross enrolment ratio (%) of Sub-Saharan Africa (developing only) in 1992 and the Gross enrolment ratio (%) of Czech Republic in 1993?
Give a very brief answer. -11.1. What is the difference between the Gross enrolment ratio (%) in Sub-Saharan Africa (developing only) in 1992 and the Gross enrolment ratio (%) in Jordan in 1993?
Make the answer very short. -17.52. What is the difference between the Gross enrolment ratio (%) of Australia in 1992 and the Gross enrolment ratio (%) of Czech Republic in 1993?
Offer a very short reply. 24.9. What is the difference between the Gross enrolment ratio (%) in Australia in 1992 and the Gross enrolment ratio (%) in Jordan in 1993?
Offer a terse response. 18.48. What is the difference between the Gross enrolment ratio (%) in Czech Republic in 1992 and the Gross enrolment ratio (%) in Jordan in 1993?
Make the answer very short. -6.3. What is the difference between the Gross enrolment ratio (%) of Sub-Saharan Africa (developing only) in 1992 and the Gross enrolment ratio (%) of Australia in 1994?
Make the answer very short. -63.11. What is the difference between the Gross enrolment ratio (%) in Sub-Saharan Africa (developing only) in 1992 and the Gross enrolment ratio (%) in Czech Republic in 1994?
Provide a succinct answer. -16.18. What is the difference between the Gross enrolment ratio (%) of Sub-Saharan Africa (developing only) in 1992 and the Gross enrolment ratio (%) of Jordan in 1994?
Make the answer very short. -15.76. What is the difference between the Gross enrolment ratio (%) in Australia in 1992 and the Gross enrolment ratio (%) in Czech Republic in 1994?
Offer a very short reply. 19.81. What is the difference between the Gross enrolment ratio (%) of Australia in 1992 and the Gross enrolment ratio (%) of Jordan in 1994?
Make the answer very short. 20.23. What is the difference between the Gross enrolment ratio (%) in Czech Republic in 1992 and the Gross enrolment ratio (%) in Jordan in 1994?
Your response must be concise. -4.54. What is the difference between the Gross enrolment ratio (%) of Sub-Saharan Africa (developing only) in 1992 and the Gross enrolment ratio (%) of Australia in 1995?
Make the answer very short. -66.79. What is the difference between the Gross enrolment ratio (%) in Sub-Saharan Africa (developing only) in 1992 and the Gross enrolment ratio (%) in Czech Republic in 1995?
Your answer should be compact. -17.37. What is the difference between the Gross enrolment ratio (%) in Sub-Saharan Africa (developing only) in 1992 and the Gross enrolment ratio (%) in Jordan in 1995?
Offer a very short reply. -15.29. What is the difference between the Gross enrolment ratio (%) in Australia in 1992 and the Gross enrolment ratio (%) in Czech Republic in 1995?
Give a very brief answer. 18.63. What is the difference between the Gross enrolment ratio (%) of Australia in 1992 and the Gross enrolment ratio (%) of Jordan in 1995?
Make the answer very short. 20.7. What is the difference between the Gross enrolment ratio (%) in Czech Republic in 1992 and the Gross enrolment ratio (%) in Jordan in 1995?
Provide a succinct answer. -4.07. What is the difference between the Gross enrolment ratio (%) of Sub-Saharan Africa (developing only) in 1993 and the Gross enrolment ratio (%) of Australia in 1994?
Provide a succinct answer. -62.93. What is the difference between the Gross enrolment ratio (%) of Sub-Saharan Africa (developing only) in 1993 and the Gross enrolment ratio (%) of Czech Republic in 1994?
Offer a very short reply. -16. What is the difference between the Gross enrolment ratio (%) in Sub-Saharan Africa (developing only) in 1993 and the Gross enrolment ratio (%) in Jordan in 1994?
Your response must be concise. -15.58. What is the difference between the Gross enrolment ratio (%) in Australia in 1993 and the Gross enrolment ratio (%) in Czech Republic in 1994?
Provide a succinct answer. 45.51. What is the difference between the Gross enrolment ratio (%) of Australia in 1993 and the Gross enrolment ratio (%) of Jordan in 1994?
Make the answer very short. 45.93. What is the difference between the Gross enrolment ratio (%) of Czech Republic in 1993 and the Gross enrolment ratio (%) of Jordan in 1994?
Keep it short and to the point. -4.66. What is the difference between the Gross enrolment ratio (%) in Sub-Saharan Africa (developing only) in 1993 and the Gross enrolment ratio (%) in Australia in 1995?
Keep it short and to the point. -66.61. What is the difference between the Gross enrolment ratio (%) in Sub-Saharan Africa (developing only) in 1993 and the Gross enrolment ratio (%) in Czech Republic in 1995?
Keep it short and to the point. -17.19. What is the difference between the Gross enrolment ratio (%) in Sub-Saharan Africa (developing only) in 1993 and the Gross enrolment ratio (%) in Jordan in 1995?
Offer a terse response. -15.11. What is the difference between the Gross enrolment ratio (%) in Australia in 1993 and the Gross enrolment ratio (%) in Czech Republic in 1995?
Provide a succinct answer. 44.33. What is the difference between the Gross enrolment ratio (%) in Australia in 1993 and the Gross enrolment ratio (%) in Jordan in 1995?
Provide a short and direct response. 46.4. What is the difference between the Gross enrolment ratio (%) of Czech Republic in 1993 and the Gross enrolment ratio (%) of Jordan in 1995?
Offer a very short reply. -4.2. What is the difference between the Gross enrolment ratio (%) of Sub-Saharan Africa (developing only) in 1994 and the Gross enrolment ratio (%) of Australia in 1995?
Your response must be concise. -66.46. What is the difference between the Gross enrolment ratio (%) of Sub-Saharan Africa (developing only) in 1994 and the Gross enrolment ratio (%) of Czech Republic in 1995?
Give a very brief answer. -17.04. What is the difference between the Gross enrolment ratio (%) of Sub-Saharan Africa (developing only) in 1994 and the Gross enrolment ratio (%) of Jordan in 1995?
Offer a terse response. -14.96. What is the difference between the Gross enrolment ratio (%) in Australia in 1994 and the Gross enrolment ratio (%) in Czech Republic in 1995?
Provide a short and direct response. 45.74. What is the difference between the Gross enrolment ratio (%) of Australia in 1994 and the Gross enrolment ratio (%) of Jordan in 1995?
Provide a succinct answer. 47.82. What is the difference between the Gross enrolment ratio (%) of Czech Republic in 1994 and the Gross enrolment ratio (%) of Jordan in 1995?
Your answer should be very brief. 0.89. What is the average Gross enrolment ratio (%) in Sub-Saharan Africa (developing only) per year?
Your answer should be very brief. 3.41. What is the average Gross enrolment ratio (%) in Australia per year?
Offer a terse response. 47.26. What is the average Gross enrolment ratio (%) in Czech Republic per year?
Give a very brief answer. 16.77. What is the average Gross enrolment ratio (%) in Jordan per year?
Offer a terse response. 20.25. In the year 1988, what is the difference between the Gross enrolment ratio (%) of Sub-Saharan Africa (developing only) and Gross enrolment ratio (%) of Australia?
Your answer should be compact. -28.27. In the year 1988, what is the difference between the Gross enrolment ratio (%) of Sub-Saharan Africa (developing only) and Gross enrolment ratio (%) of Czech Republic?
Your response must be concise. -13.35. In the year 1988, what is the difference between the Gross enrolment ratio (%) of Sub-Saharan Africa (developing only) and Gross enrolment ratio (%) of Jordan?
Your answer should be very brief. -15.54. In the year 1988, what is the difference between the Gross enrolment ratio (%) in Australia and Gross enrolment ratio (%) in Czech Republic?
Ensure brevity in your answer.  14.92. In the year 1988, what is the difference between the Gross enrolment ratio (%) of Australia and Gross enrolment ratio (%) of Jordan?
Keep it short and to the point. 12.73. In the year 1988, what is the difference between the Gross enrolment ratio (%) in Czech Republic and Gross enrolment ratio (%) in Jordan?
Provide a succinct answer. -2.2. In the year 1989, what is the difference between the Gross enrolment ratio (%) of Sub-Saharan Africa (developing only) and Gross enrolment ratio (%) of Australia?
Provide a succinct answer. -29.25. In the year 1989, what is the difference between the Gross enrolment ratio (%) of Sub-Saharan Africa (developing only) and Gross enrolment ratio (%) of Czech Republic?
Offer a terse response. -13.01. In the year 1989, what is the difference between the Gross enrolment ratio (%) in Sub-Saharan Africa (developing only) and Gross enrolment ratio (%) in Jordan?
Your answer should be very brief. -17.46. In the year 1989, what is the difference between the Gross enrolment ratio (%) in Australia and Gross enrolment ratio (%) in Czech Republic?
Offer a very short reply. 16.24. In the year 1989, what is the difference between the Gross enrolment ratio (%) in Australia and Gross enrolment ratio (%) in Jordan?
Provide a short and direct response. 11.79. In the year 1989, what is the difference between the Gross enrolment ratio (%) of Czech Republic and Gross enrolment ratio (%) of Jordan?
Offer a terse response. -4.45. In the year 1990, what is the difference between the Gross enrolment ratio (%) of Sub-Saharan Africa (developing only) and Gross enrolment ratio (%) of Australia?
Offer a terse response. -31.87. In the year 1990, what is the difference between the Gross enrolment ratio (%) in Sub-Saharan Africa (developing only) and Gross enrolment ratio (%) in Czech Republic?
Keep it short and to the point. -12.84. In the year 1990, what is the difference between the Gross enrolment ratio (%) of Sub-Saharan Africa (developing only) and Gross enrolment ratio (%) of Jordan?
Give a very brief answer. -17.24. In the year 1990, what is the difference between the Gross enrolment ratio (%) of Australia and Gross enrolment ratio (%) of Czech Republic?
Offer a terse response. 19.03. In the year 1990, what is the difference between the Gross enrolment ratio (%) of Australia and Gross enrolment ratio (%) of Jordan?
Give a very brief answer. 14.63. In the year 1990, what is the difference between the Gross enrolment ratio (%) in Czech Republic and Gross enrolment ratio (%) in Jordan?
Make the answer very short. -4.4. In the year 1991, what is the difference between the Gross enrolment ratio (%) of Sub-Saharan Africa (developing only) and Gross enrolment ratio (%) of Australia?
Make the answer very short. -34.7. In the year 1991, what is the difference between the Gross enrolment ratio (%) of Sub-Saharan Africa (developing only) and Gross enrolment ratio (%) of Czech Republic?
Your response must be concise. -12.71. In the year 1991, what is the difference between the Gross enrolment ratio (%) of Sub-Saharan Africa (developing only) and Gross enrolment ratio (%) of Jordan?
Your response must be concise. -18.87. In the year 1991, what is the difference between the Gross enrolment ratio (%) of Australia and Gross enrolment ratio (%) of Czech Republic?
Keep it short and to the point. 21.99. In the year 1991, what is the difference between the Gross enrolment ratio (%) of Australia and Gross enrolment ratio (%) of Jordan?
Offer a very short reply. 15.82. In the year 1991, what is the difference between the Gross enrolment ratio (%) in Czech Republic and Gross enrolment ratio (%) in Jordan?
Make the answer very short. -6.16. In the year 1992, what is the difference between the Gross enrolment ratio (%) in Sub-Saharan Africa (developing only) and Gross enrolment ratio (%) in Australia?
Provide a succinct answer. -35.99. In the year 1992, what is the difference between the Gross enrolment ratio (%) of Sub-Saharan Africa (developing only) and Gross enrolment ratio (%) of Czech Republic?
Offer a very short reply. -11.22. In the year 1992, what is the difference between the Gross enrolment ratio (%) in Sub-Saharan Africa (developing only) and Gross enrolment ratio (%) in Jordan?
Your answer should be compact. -17.99. In the year 1992, what is the difference between the Gross enrolment ratio (%) in Australia and Gross enrolment ratio (%) in Czech Republic?
Your answer should be compact. 24.77. In the year 1992, what is the difference between the Gross enrolment ratio (%) of Australia and Gross enrolment ratio (%) of Jordan?
Your answer should be very brief. 18.01. In the year 1992, what is the difference between the Gross enrolment ratio (%) in Czech Republic and Gross enrolment ratio (%) in Jordan?
Your response must be concise. -6.77. In the year 1993, what is the difference between the Gross enrolment ratio (%) of Sub-Saharan Africa (developing only) and Gross enrolment ratio (%) of Australia?
Ensure brevity in your answer.  -61.51. In the year 1993, what is the difference between the Gross enrolment ratio (%) in Sub-Saharan Africa (developing only) and Gross enrolment ratio (%) in Czech Republic?
Your answer should be very brief. -10.92. In the year 1993, what is the difference between the Gross enrolment ratio (%) in Sub-Saharan Africa (developing only) and Gross enrolment ratio (%) in Jordan?
Keep it short and to the point. -17.33. In the year 1993, what is the difference between the Gross enrolment ratio (%) of Australia and Gross enrolment ratio (%) of Czech Republic?
Your answer should be compact. 50.6. In the year 1993, what is the difference between the Gross enrolment ratio (%) in Australia and Gross enrolment ratio (%) in Jordan?
Offer a terse response. 44.18. In the year 1993, what is the difference between the Gross enrolment ratio (%) of Czech Republic and Gross enrolment ratio (%) of Jordan?
Ensure brevity in your answer.  -6.42. In the year 1994, what is the difference between the Gross enrolment ratio (%) in Sub-Saharan Africa (developing only) and Gross enrolment ratio (%) in Australia?
Provide a short and direct response. -62.78. In the year 1994, what is the difference between the Gross enrolment ratio (%) of Sub-Saharan Africa (developing only) and Gross enrolment ratio (%) of Czech Republic?
Offer a very short reply. -15.86. In the year 1994, what is the difference between the Gross enrolment ratio (%) in Sub-Saharan Africa (developing only) and Gross enrolment ratio (%) in Jordan?
Ensure brevity in your answer.  -15.43. In the year 1994, what is the difference between the Gross enrolment ratio (%) in Australia and Gross enrolment ratio (%) in Czech Republic?
Provide a succinct answer. 46.93. In the year 1994, what is the difference between the Gross enrolment ratio (%) in Australia and Gross enrolment ratio (%) in Jordan?
Make the answer very short. 47.35. In the year 1994, what is the difference between the Gross enrolment ratio (%) in Czech Republic and Gross enrolment ratio (%) in Jordan?
Offer a terse response. 0.43. In the year 1995, what is the difference between the Gross enrolment ratio (%) in Sub-Saharan Africa (developing only) and Gross enrolment ratio (%) in Australia?
Your answer should be very brief. -66.39. In the year 1995, what is the difference between the Gross enrolment ratio (%) in Sub-Saharan Africa (developing only) and Gross enrolment ratio (%) in Czech Republic?
Offer a terse response. -16.97. In the year 1995, what is the difference between the Gross enrolment ratio (%) in Sub-Saharan Africa (developing only) and Gross enrolment ratio (%) in Jordan?
Ensure brevity in your answer.  -14.89. In the year 1995, what is the difference between the Gross enrolment ratio (%) of Australia and Gross enrolment ratio (%) of Czech Republic?
Offer a terse response. 49.42. In the year 1995, what is the difference between the Gross enrolment ratio (%) in Australia and Gross enrolment ratio (%) in Jordan?
Your response must be concise. 51.5. In the year 1995, what is the difference between the Gross enrolment ratio (%) of Czech Republic and Gross enrolment ratio (%) of Jordan?
Your answer should be very brief. 2.07. What is the ratio of the Gross enrolment ratio (%) of Sub-Saharan Africa (developing only) in 1988 to that in 1989?
Your answer should be very brief. 0.95. What is the ratio of the Gross enrolment ratio (%) of Australia in 1988 to that in 1989?
Keep it short and to the point. 0.97. What is the ratio of the Gross enrolment ratio (%) of Czech Republic in 1988 to that in 1989?
Ensure brevity in your answer.  1.01. What is the ratio of the Gross enrolment ratio (%) in Jordan in 1988 to that in 1989?
Make the answer very short. 0.9. What is the ratio of the Gross enrolment ratio (%) of Sub-Saharan Africa (developing only) in 1988 to that in 1990?
Ensure brevity in your answer.  0.93. What is the ratio of the Gross enrolment ratio (%) in Australia in 1988 to that in 1990?
Give a very brief answer. 0.89. What is the ratio of the Gross enrolment ratio (%) of Czech Republic in 1988 to that in 1990?
Offer a terse response. 1.02. What is the ratio of the Gross enrolment ratio (%) in Jordan in 1988 to that in 1990?
Give a very brief answer. 0.91. What is the ratio of the Gross enrolment ratio (%) in Sub-Saharan Africa (developing only) in 1988 to that in 1991?
Make the answer very short. 0.9. What is the ratio of the Gross enrolment ratio (%) of Australia in 1988 to that in 1991?
Make the answer very short. 0.82. What is the ratio of the Gross enrolment ratio (%) in Czech Republic in 1988 to that in 1991?
Your response must be concise. 1.02. What is the ratio of the Gross enrolment ratio (%) of Jordan in 1988 to that in 1991?
Ensure brevity in your answer.  0.84. What is the ratio of the Gross enrolment ratio (%) in Sub-Saharan Africa (developing only) in 1988 to that in 1992?
Make the answer very short. 0.88. What is the ratio of the Gross enrolment ratio (%) in Australia in 1988 to that in 1992?
Offer a terse response. 0.79. What is the ratio of the Gross enrolment ratio (%) of Czech Republic in 1988 to that in 1992?
Your answer should be very brief. 1.12. What is the ratio of the Gross enrolment ratio (%) in Jordan in 1988 to that in 1992?
Your response must be concise. 0.87. What is the ratio of the Gross enrolment ratio (%) of Sub-Saharan Africa (developing only) in 1988 to that in 1993?
Ensure brevity in your answer.  0.83. What is the ratio of the Gross enrolment ratio (%) in Australia in 1988 to that in 1993?
Your answer should be compact. 0.48. What is the ratio of the Gross enrolment ratio (%) in Czech Republic in 1988 to that in 1993?
Make the answer very short. 1.13. What is the ratio of the Gross enrolment ratio (%) of Jordan in 1988 to that in 1993?
Make the answer very short. 0.89. What is the ratio of the Gross enrolment ratio (%) of Sub-Saharan Africa (developing only) in 1988 to that in 1994?
Offer a terse response. 0.8. What is the ratio of the Gross enrolment ratio (%) in Australia in 1988 to that in 1994?
Ensure brevity in your answer.  0.47. What is the ratio of the Gross enrolment ratio (%) in Czech Republic in 1988 to that in 1994?
Keep it short and to the point. 0.83. What is the ratio of the Gross enrolment ratio (%) in Jordan in 1988 to that in 1994?
Offer a terse response. 0.97. What is the ratio of the Gross enrolment ratio (%) of Sub-Saharan Africa (developing only) in 1988 to that in 1995?
Provide a succinct answer. 0.79. What is the ratio of the Gross enrolment ratio (%) of Australia in 1988 to that in 1995?
Your answer should be compact. 0.45. What is the ratio of the Gross enrolment ratio (%) of Czech Republic in 1988 to that in 1995?
Provide a short and direct response. 0.79. What is the ratio of the Gross enrolment ratio (%) of Sub-Saharan Africa (developing only) in 1989 to that in 1990?
Provide a short and direct response. 0.98. What is the ratio of the Gross enrolment ratio (%) of Australia in 1989 to that in 1990?
Ensure brevity in your answer.  0.92. What is the ratio of the Gross enrolment ratio (%) in Czech Republic in 1989 to that in 1990?
Keep it short and to the point. 1.01. What is the ratio of the Gross enrolment ratio (%) in Jordan in 1989 to that in 1990?
Offer a very short reply. 1.01. What is the ratio of the Gross enrolment ratio (%) of Sub-Saharan Africa (developing only) in 1989 to that in 1991?
Your answer should be very brief. 0.95. What is the ratio of the Gross enrolment ratio (%) of Australia in 1989 to that in 1991?
Your answer should be compact. 0.85. What is the ratio of the Gross enrolment ratio (%) of Czech Republic in 1989 to that in 1991?
Provide a short and direct response. 1.01. What is the ratio of the Gross enrolment ratio (%) in Jordan in 1989 to that in 1991?
Ensure brevity in your answer.  0.93. What is the ratio of the Gross enrolment ratio (%) in Sub-Saharan Africa (developing only) in 1989 to that in 1992?
Your answer should be very brief. 0.92. What is the ratio of the Gross enrolment ratio (%) of Australia in 1989 to that in 1992?
Offer a very short reply. 0.82. What is the ratio of the Gross enrolment ratio (%) of Czech Republic in 1989 to that in 1992?
Give a very brief answer. 1.1. What is the ratio of the Gross enrolment ratio (%) in Sub-Saharan Africa (developing only) in 1989 to that in 1993?
Your response must be concise. 0.88. What is the ratio of the Gross enrolment ratio (%) of Australia in 1989 to that in 1993?
Your answer should be very brief. 0.5. What is the ratio of the Gross enrolment ratio (%) in Czech Republic in 1989 to that in 1993?
Offer a very short reply. 1.11. What is the ratio of the Gross enrolment ratio (%) of Jordan in 1989 to that in 1993?
Give a very brief answer. 0.98. What is the ratio of the Gross enrolment ratio (%) of Sub-Saharan Africa (developing only) in 1989 to that in 1994?
Keep it short and to the point. 0.84. What is the ratio of the Gross enrolment ratio (%) of Australia in 1989 to that in 1994?
Your answer should be very brief. 0.49. What is the ratio of the Gross enrolment ratio (%) in Czech Republic in 1989 to that in 1994?
Provide a short and direct response. 0.82. What is the ratio of the Gross enrolment ratio (%) in Jordan in 1989 to that in 1994?
Keep it short and to the point. 1.07. What is the ratio of the Gross enrolment ratio (%) in Sub-Saharan Africa (developing only) in 1989 to that in 1995?
Give a very brief answer. 0.83. What is the ratio of the Gross enrolment ratio (%) in Australia in 1989 to that in 1995?
Offer a terse response. 0.46. What is the ratio of the Gross enrolment ratio (%) in Czech Republic in 1989 to that in 1995?
Offer a very short reply. 0.78. What is the ratio of the Gross enrolment ratio (%) in Jordan in 1989 to that in 1995?
Keep it short and to the point. 1.1. What is the ratio of the Gross enrolment ratio (%) of Australia in 1990 to that in 1991?
Offer a terse response. 0.92. What is the ratio of the Gross enrolment ratio (%) of Czech Republic in 1990 to that in 1991?
Offer a terse response. 1. What is the ratio of the Gross enrolment ratio (%) in Jordan in 1990 to that in 1991?
Your response must be concise. 0.92. What is the ratio of the Gross enrolment ratio (%) of Sub-Saharan Africa (developing only) in 1990 to that in 1992?
Keep it short and to the point. 0.94. What is the ratio of the Gross enrolment ratio (%) of Australia in 1990 to that in 1992?
Give a very brief answer. 0.89. What is the ratio of the Gross enrolment ratio (%) of Czech Republic in 1990 to that in 1992?
Offer a terse response. 1.1. What is the ratio of the Gross enrolment ratio (%) of Jordan in 1990 to that in 1992?
Ensure brevity in your answer.  0.96. What is the ratio of the Gross enrolment ratio (%) of Sub-Saharan Africa (developing only) in 1990 to that in 1993?
Offer a terse response. 0.89. What is the ratio of the Gross enrolment ratio (%) in Australia in 1990 to that in 1993?
Your answer should be very brief. 0.54. What is the ratio of the Gross enrolment ratio (%) in Czech Republic in 1990 to that in 1993?
Make the answer very short. 1.11. What is the ratio of the Gross enrolment ratio (%) of Jordan in 1990 to that in 1993?
Ensure brevity in your answer.  0.98. What is the ratio of the Gross enrolment ratio (%) in Sub-Saharan Africa (developing only) in 1990 to that in 1994?
Your answer should be compact. 0.86. What is the ratio of the Gross enrolment ratio (%) in Australia in 1990 to that in 1994?
Keep it short and to the point. 0.53. What is the ratio of the Gross enrolment ratio (%) of Czech Republic in 1990 to that in 1994?
Your answer should be compact. 0.82. What is the ratio of the Gross enrolment ratio (%) of Jordan in 1990 to that in 1994?
Provide a succinct answer. 1.07. What is the ratio of the Gross enrolment ratio (%) of Sub-Saharan Africa (developing only) in 1990 to that in 1995?
Provide a short and direct response. 0.84. What is the ratio of the Gross enrolment ratio (%) in Australia in 1990 to that in 1995?
Your response must be concise. 0.5. What is the ratio of the Gross enrolment ratio (%) of Czech Republic in 1990 to that in 1995?
Your answer should be compact. 0.77. What is the ratio of the Gross enrolment ratio (%) of Jordan in 1990 to that in 1995?
Provide a succinct answer. 1.09. What is the ratio of the Gross enrolment ratio (%) in Sub-Saharan Africa (developing only) in 1991 to that in 1992?
Offer a very short reply. 0.97. What is the ratio of the Gross enrolment ratio (%) of Australia in 1991 to that in 1992?
Provide a succinct answer. 0.96. What is the ratio of the Gross enrolment ratio (%) in Czech Republic in 1991 to that in 1992?
Provide a short and direct response. 1.1. What is the ratio of the Gross enrolment ratio (%) of Jordan in 1991 to that in 1992?
Provide a succinct answer. 1.04. What is the ratio of the Gross enrolment ratio (%) of Sub-Saharan Africa (developing only) in 1991 to that in 1993?
Keep it short and to the point. 0.92. What is the ratio of the Gross enrolment ratio (%) of Australia in 1991 to that in 1993?
Your answer should be very brief. 0.58. What is the ratio of the Gross enrolment ratio (%) of Czech Republic in 1991 to that in 1993?
Provide a short and direct response. 1.1. What is the ratio of the Gross enrolment ratio (%) in Jordan in 1991 to that in 1993?
Keep it short and to the point. 1.06. What is the ratio of the Gross enrolment ratio (%) of Sub-Saharan Africa (developing only) in 1991 to that in 1994?
Offer a very short reply. 0.89. What is the ratio of the Gross enrolment ratio (%) in Australia in 1991 to that in 1994?
Your answer should be compact. 0.57. What is the ratio of the Gross enrolment ratio (%) of Czech Republic in 1991 to that in 1994?
Provide a succinct answer. 0.82. What is the ratio of the Gross enrolment ratio (%) in Jordan in 1991 to that in 1994?
Provide a succinct answer. 1.16. What is the ratio of the Gross enrolment ratio (%) of Sub-Saharan Africa (developing only) in 1991 to that in 1995?
Ensure brevity in your answer.  0.87. What is the ratio of the Gross enrolment ratio (%) in Australia in 1991 to that in 1995?
Provide a succinct answer. 0.54. What is the ratio of the Gross enrolment ratio (%) in Czech Republic in 1991 to that in 1995?
Give a very brief answer. 0.77. What is the ratio of the Gross enrolment ratio (%) in Jordan in 1991 to that in 1995?
Give a very brief answer. 1.19. What is the ratio of the Gross enrolment ratio (%) of Sub-Saharan Africa (developing only) in 1992 to that in 1993?
Ensure brevity in your answer.  0.95. What is the ratio of the Gross enrolment ratio (%) of Australia in 1992 to that in 1993?
Offer a very short reply. 0.61. What is the ratio of the Gross enrolment ratio (%) of Czech Republic in 1992 to that in 1993?
Your response must be concise. 1.01. What is the ratio of the Gross enrolment ratio (%) in Jordan in 1992 to that in 1993?
Ensure brevity in your answer.  1.02. What is the ratio of the Gross enrolment ratio (%) in Sub-Saharan Africa (developing only) in 1992 to that in 1994?
Make the answer very short. 0.91. What is the ratio of the Gross enrolment ratio (%) in Australia in 1992 to that in 1994?
Your response must be concise. 0.59. What is the ratio of the Gross enrolment ratio (%) in Czech Republic in 1992 to that in 1994?
Provide a succinct answer. 0.75. What is the ratio of the Gross enrolment ratio (%) in Jordan in 1992 to that in 1994?
Give a very brief answer. 1.12. What is the ratio of the Gross enrolment ratio (%) of Sub-Saharan Africa (developing only) in 1992 to that in 1995?
Give a very brief answer. 0.9. What is the ratio of the Gross enrolment ratio (%) in Australia in 1992 to that in 1995?
Give a very brief answer. 0.56. What is the ratio of the Gross enrolment ratio (%) of Czech Republic in 1992 to that in 1995?
Offer a terse response. 0.7. What is the ratio of the Gross enrolment ratio (%) in Jordan in 1992 to that in 1995?
Provide a short and direct response. 1.14. What is the ratio of the Gross enrolment ratio (%) in Sub-Saharan Africa (developing only) in 1993 to that in 1994?
Your response must be concise. 0.96. What is the ratio of the Gross enrolment ratio (%) of Australia in 1993 to that in 1994?
Keep it short and to the point. 0.98. What is the ratio of the Gross enrolment ratio (%) of Czech Republic in 1993 to that in 1994?
Your response must be concise. 0.74. What is the ratio of the Gross enrolment ratio (%) in Jordan in 1993 to that in 1994?
Offer a terse response. 1.09. What is the ratio of the Gross enrolment ratio (%) in Sub-Saharan Africa (developing only) in 1993 to that in 1995?
Offer a very short reply. 0.94. What is the ratio of the Gross enrolment ratio (%) of Australia in 1993 to that in 1995?
Make the answer very short. 0.93. What is the ratio of the Gross enrolment ratio (%) of Czech Republic in 1993 to that in 1995?
Your answer should be very brief. 0.7. What is the ratio of the Gross enrolment ratio (%) of Jordan in 1993 to that in 1995?
Offer a very short reply. 1.12. What is the ratio of the Gross enrolment ratio (%) of Sub-Saharan Africa (developing only) in 1994 to that in 1995?
Your answer should be very brief. 0.98. What is the ratio of the Gross enrolment ratio (%) of Australia in 1994 to that in 1995?
Provide a short and direct response. 0.95. What is the ratio of the Gross enrolment ratio (%) in Czech Republic in 1994 to that in 1995?
Your answer should be compact. 0.94. What is the ratio of the Gross enrolment ratio (%) in Jordan in 1994 to that in 1995?
Provide a short and direct response. 1.02. What is the difference between the highest and the second highest Gross enrolment ratio (%) in Sub-Saharan Africa (developing only)?
Offer a terse response. 0.07. What is the difference between the highest and the second highest Gross enrolment ratio (%) in Australia?
Ensure brevity in your answer.  3.68. What is the difference between the highest and the second highest Gross enrolment ratio (%) of Czech Republic?
Make the answer very short. 1.18. What is the difference between the highest and the second highest Gross enrolment ratio (%) of Jordan?
Your response must be concise. 0.79. What is the difference between the highest and the lowest Gross enrolment ratio (%) in Sub-Saharan Africa (developing only)?
Your answer should be very brief. 0.81. What is the difference between the highest and the lowest Gross enrolment ratio (%) in Australia?
Give a very brief answer. 38.93. What is the difference between the highest and the lowest Gross enrolment ratio (%) in Czech Republic?
Ensure brevity in your answer.  6.27. What is the difference between the highest and the lowest Gross enrolment ratio (%) of Jordan?
Make the answer very short. 3.65. 